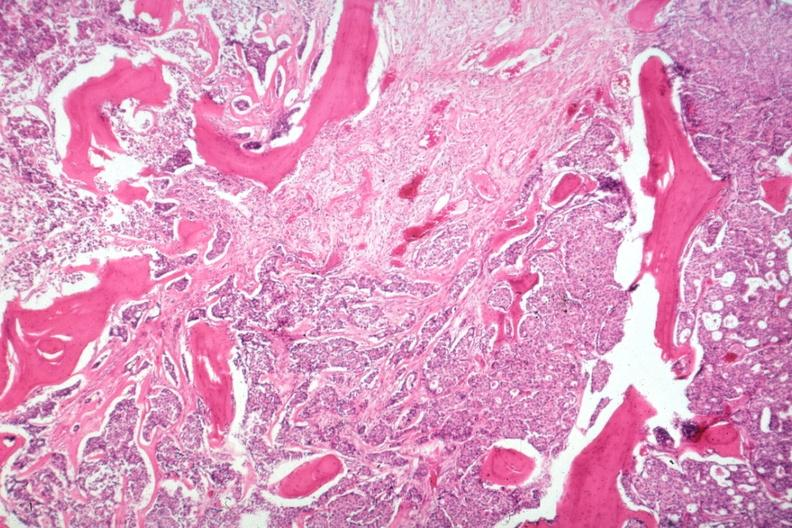s gross islands of tumor?
Answer the question using a single word or phrase. Yes 